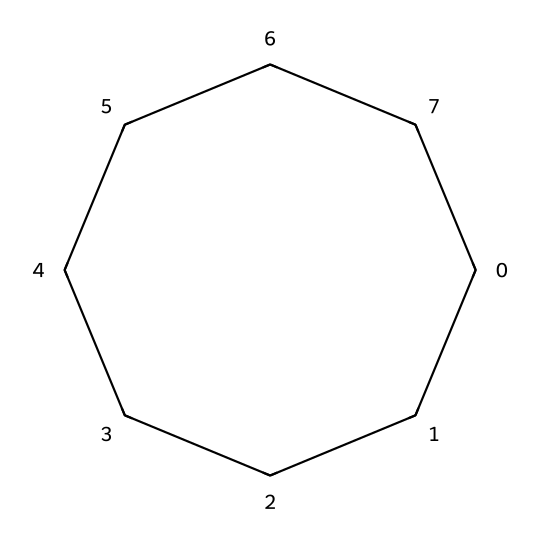What is the total number of carbon atoms in cyclooctane? The SMILES representation shows eight 'C' atoms, indicating that cyclooctane contains eight carbon atoms.
Answer: eight How many hydrogen atoms are present in cyclooctane? For a cycloalkane, the general formula is CnH2n. Here, n is 8, so H = 2(8) = 16. Therefore, cyclooctane has 16 hydrogen atoms.
Answer: sixteen What is the structure of cyclooctane? The SMILES notation indicates a cyclic structure with several carbon atoms connected in a ring, confirming that it is a cycloalkane.
Answer: cyclic Is cyclooctane saturated or unsaturated? Since cyclooctane contains only single bonds between its carbon atoms, it is classified as a saturated hydrocarbon.
Answer: saturated What type of bonds are present in cyclooctane? The structure shows that all carbon atoms are connected by single covalent bonds, characteristic of saturated hydrocarbons like cycloalkanes.
Answer: single bonds Why does cyclooctane have a higher boiling point than smaller cycloalkanes? As the size of the cycloalkane increases, the surface area also increases, leading to enhanced van der Waals forces, thus a higher boiling point.
Answer: higher boiling point What properties make cyclooctane suitable for adhesives and sealants? Cyclooctane's saturated structure and lack of functional groups contribute to its stability and low reactivity, making it an excellent choice for adhesives and sealants.
Answer: stability and low reactivity 